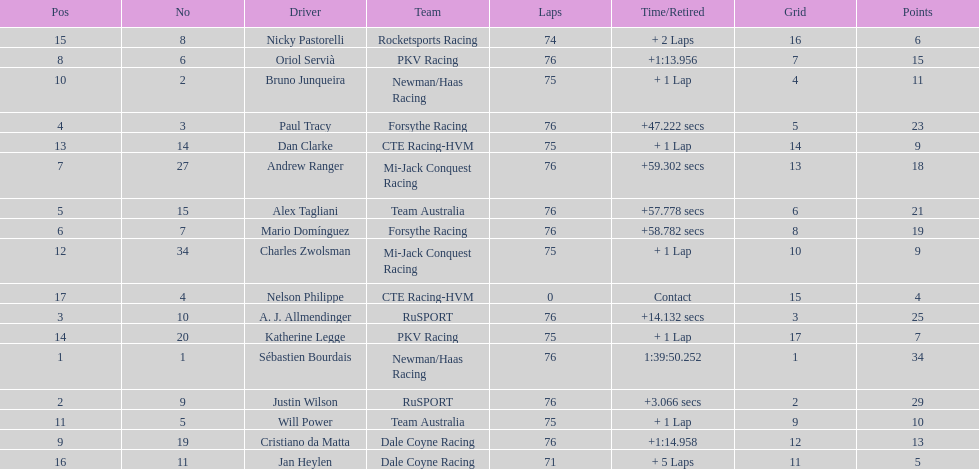Which driver earned the least amount of points. Nelson Philippe. 